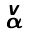<formula> <loc_0><loc_0><loc_500><loc_500>\begin{smallmatrix} v \\ \alpha \end{smallmatrix}</formula> 